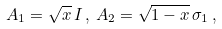Convert formula to latex. <formula><loc_0><loc_0><loc_500><loc_500>A _ { 1 } = \sqrt { x } \, I \, , \, A _ { 2 } = \sqrt { 1 - x } \, \sigma _ { 1 } \, , \,</formula> 